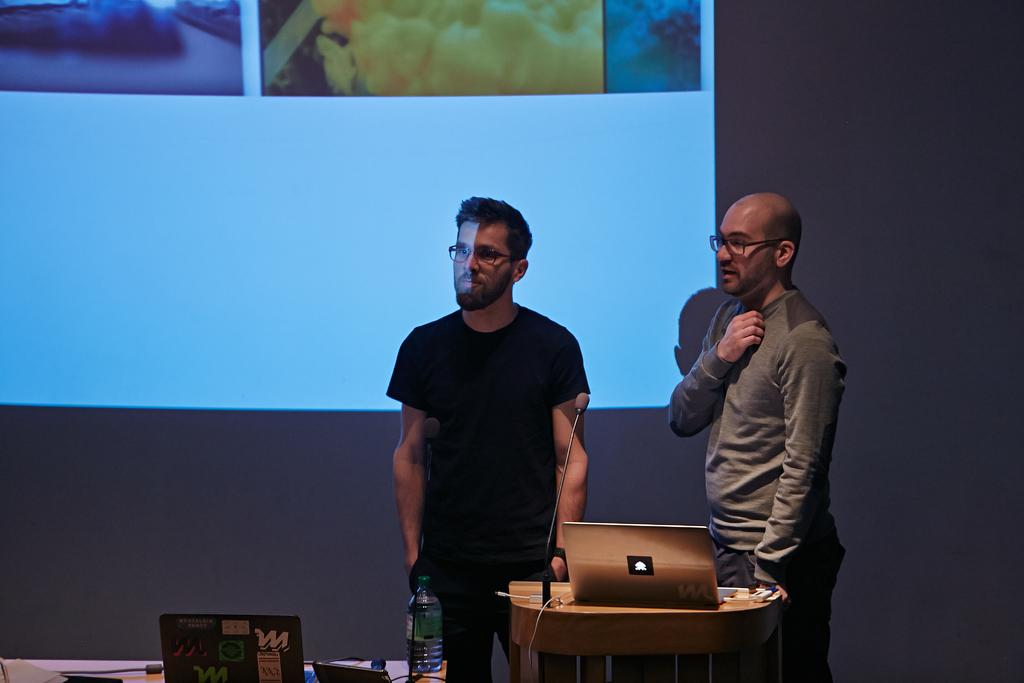What is the main object in the image? There is a screen in the image. What else can be seen in the background of the image? There is a wall in the image. How many people are present in the image? There are two people standing in the image. What object might be used for amplifying sound or recording audio? There is a microphone (mike) in the image. What device is likely being used for displaying information or presentations? There is a laptop in the image. What object might be used for holding a beverage? There is a bottle in the image. What type of fiction is being taught by the people in the image? There is no indication in the image that the people are teaching or discussing fiction. 